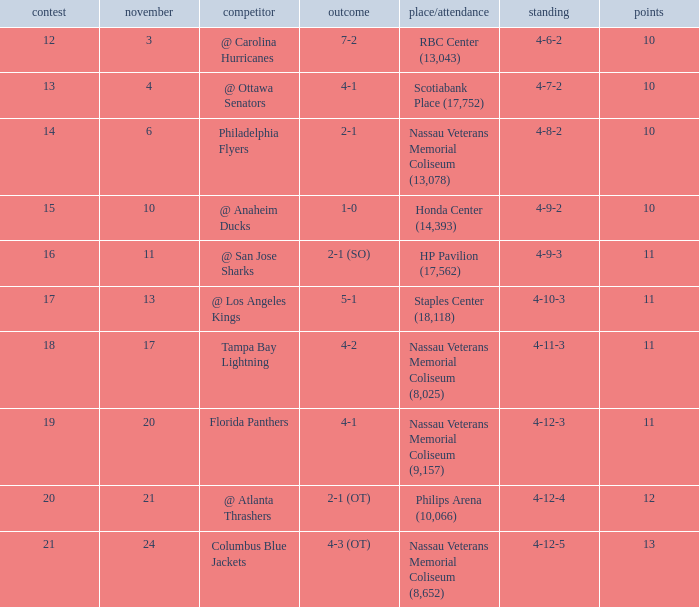What is the lowest entry point for a game where the score is 1-0? 15.0. 